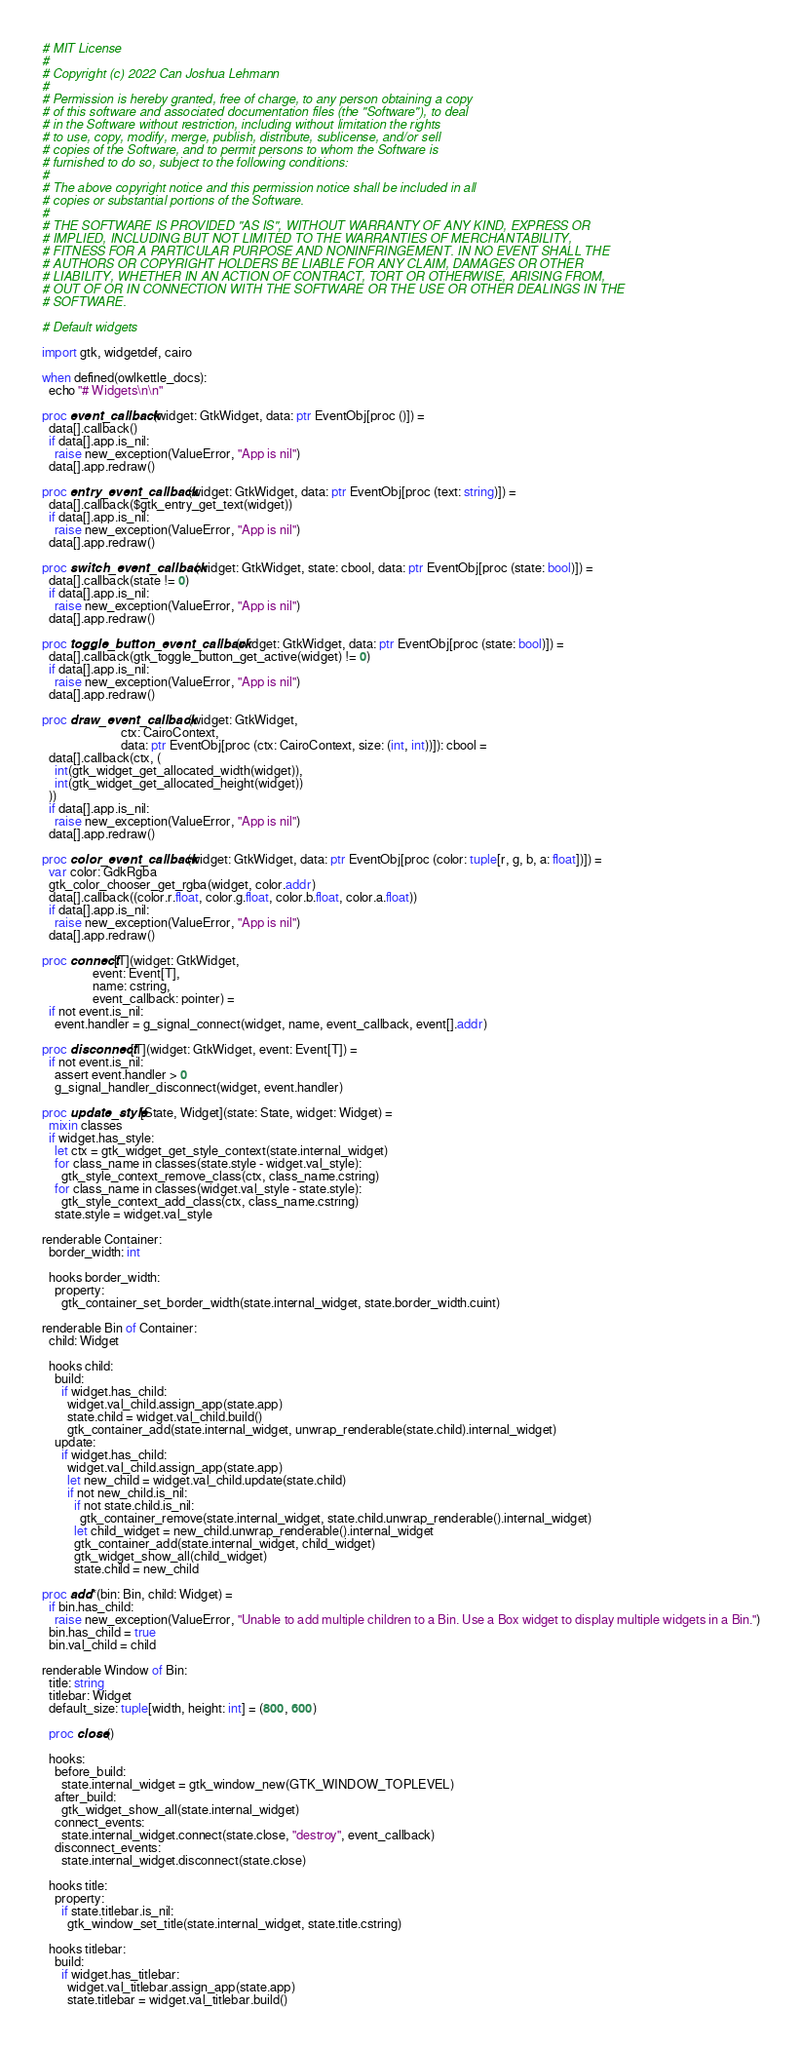<code> <loc_0><loc_0><loc_500><loc_500><_Nim_># MIT License
# 
# Copyright (c) 2022 Can Joshua Lehmann
# 
# Permission is hereby granted, free of charge, to any person obtaining a copy
# of this software and associated documentation files (the "Software"), to deal
# in the Software without restriction, including without limitation the rights
# to use, copy, modify, merge, publish, distribute, sublicense, and/or sell
# copies of the Software, and to permit persons to whom the Software is
# furnished to do so, subject to the following conditions:
# 
# The above copyright notice and this permission notice shall be included in all
# copies or substantial portions of the Software.
# 
# THE SOFTWARE IS PROVIDED "AS IS", WITHOUT WARRANTY OF ANY KIND, EXPRESS OR
# IMPLIED, INCLUDING BUT NOT LIMITED TO THE WARRANTIES OF MERCHANTABILITY,
# FITNESS FOR A PARTICULAR PURPOSE AND NONINFRINGEMENT. IN NO EVENT SHALL THE
# AUTHORS OR COPYRIGHT HOLDERS BE LIABLE FOR ANY CLAIM, DAMAGES OR OTHER
# LIABILITY, WHETHER IN AN ACTION OF CONTRACT, TORT OR OTHERWISE, ARISING FROM,
# OUT OF OR IN CONNECTION WITH THE SOFTWARE OR THE USE OR OTHER DEALINGS IN THE
# SOFTWARE.

# Default widgets

import gtk, widgetdef, cairo

when defined(owlkettle_docs):
  echo "# Widgets\n\n"

proc event_callback(widget: GtkWidget, data: ptr EventObj[proc ()]) =
  data[].callback()
  if data[].app.is_nil:
    raise new_exception(ValueError, "App is nil")
  data[].app.redraw()

proc entry_event_callback(widget: GtkWidget, data: ptr EventObj[proc (text: string)]) =
  data[].callback($gtk_entry_get_text(widget))
  if data[].app.is_nil:
    raise new_exception(ValueError, "App is nil")
  data[].app.redraw()

proc switch_event_callback(widget: GtkWidget, state: cbool, data: ptr EventObj[proc (state: bool)]) =
  data[].callback(state != 0)
  if data[].app.is_nil:
    raise new_exception(ValueError, "App is nil")
  data[].app.redraw()

proc toggle_button_event_callback(widget: GtkWidget, data: ptr EventObj[proc (state: bool)]) =
  data[].callback(gtk_toggle_button_get_active(widget) != 0)
  if data[].app.is_nil:
    raise new_exception(ValueError, "App is nil")
  data[].app.redraw()

proc draw_event_callback(widget: GtkWidget,
                         ctx: CairoContext,
                         data: ptr EventObj[proc (ctx: CairoContext, size: (int, int))]): cbool =
  data[].callback(ctx, (
    int(gtk_widget_get_allocated_width(widget)),
    int(gtk_widget_get_allocated_height(widget))
  ))
  if data[].app.is_nil:
    raise new_exception(ValueError, "App is nil")
  data[].app.redraw()

proc color_event_callback(widget: GtkWidget, data: ptr EventObj[proc (color: tuple[r, g, b, a: float])]) =
  var color: GdkRgba
  gtk_color_chooser_get_rgba(widget, color.addr)
  data[].callback((color.r.float, color.g.float, color.b.float, color.a.float))
  if data[].app.is_nil:
    raise new_exception(ValueError, "App is nil")
  data[].app.redraw()

proc connect[T](widget: GtkWidget,
                event: Event[T],
                name: cstring,
                event_callback: pointer) =
  if not event.is_nil:
    event.handler = g_signal_connect(widget, name, event_callback, event[].addr)

proc disconnect[T](widget: GtkWidget, event: Event[T]) =
  if not event.is_nil:
    assert event.handler > 0
    g_signal_handler_disconnect(widget, event.handler)

proc update_style[State, Widget](state: State, widget: Widget) =
  mixin classes
  if widget.has_style:
    let ctx = gtk_widget_get_style_context(state.internal_widget)
    for class_name in classes(state.style - widget.val_style):
      gtk_style_context_remove_class(ctx, class_name.cstring)
    for class_name in classes(widget.val_style - state.style):
      gtk_style_context_add_class(ctx, class_name.cstring)
    state.style = widget.val_style

renderable Container:
  border_width: int
  
  hooks border_width:
    property:
      gtk_container_set_border_width(state.internal_widget, state.border_width.cuint)

renderable Bin of Container:
  child: Widget
  
  hooks child:
    build:
      if widget.has_child:
        widget.val_child.assign_app(state.app)
        state.child = widget.val_child.build()
        gtk_container_add(state.internal_widget, unwrap_renderable(state.child).internal_widget)
    update:
      if widget.has_child:
        widget.val_child.assign_app(state.app)
        let new_child = widget.val_child.update(state.child)
        if not new_child.is_nil:
          if not state.child.is_nil:
            gtk_container_remove(state.internal_widget, state.child.unwrap_renderable().internal_widget)
          let child_widget = new_child.unwrap_renderable().internal_widget
          gtk_container_add(state.internal_widget, child_widget)
          gtk_widget_show_all(child_widget)
          state.child = new_child

proc add*(bin: Bin, child: Widget) =
  if bin.has_child:
    raise new_exception(ValueError, "Unable to add multiple children to a Bin. Use a Box widget to display multiple widgets in a Bin.")
  bin.has_child = true
  bin.val_child = child

renderable Window of Bin:
  title: string
  titlebar: Widget
  default_size: tuple[width, height: int] = (800, 600)
  
  proc close()
  
  hooks:
    before_build:
      state.internal_widget = gtk_window_new(GTK_WINDOW_TOPLEVEL)
    after_build:
      gtk_widget_show_all(state.internal_widget)
    connect_events:
      state.internal_widget.connect(state.close, "destroy", event_callback)
    disconnect_events:
      state.internal_widget.disconnect(state.close)
  
  hooks title:
    property:
      if state.titlebar.is_nil:
        gtk_window_set_title(state.internal_widget, state.title.cstring)
  
  hooks titlebar:
    build:
      if widget.has_titlebar:
        widget.val_titlebar.assign_app(state.app)
        state.titlebar = widget.val_titlebar.build()</code> 